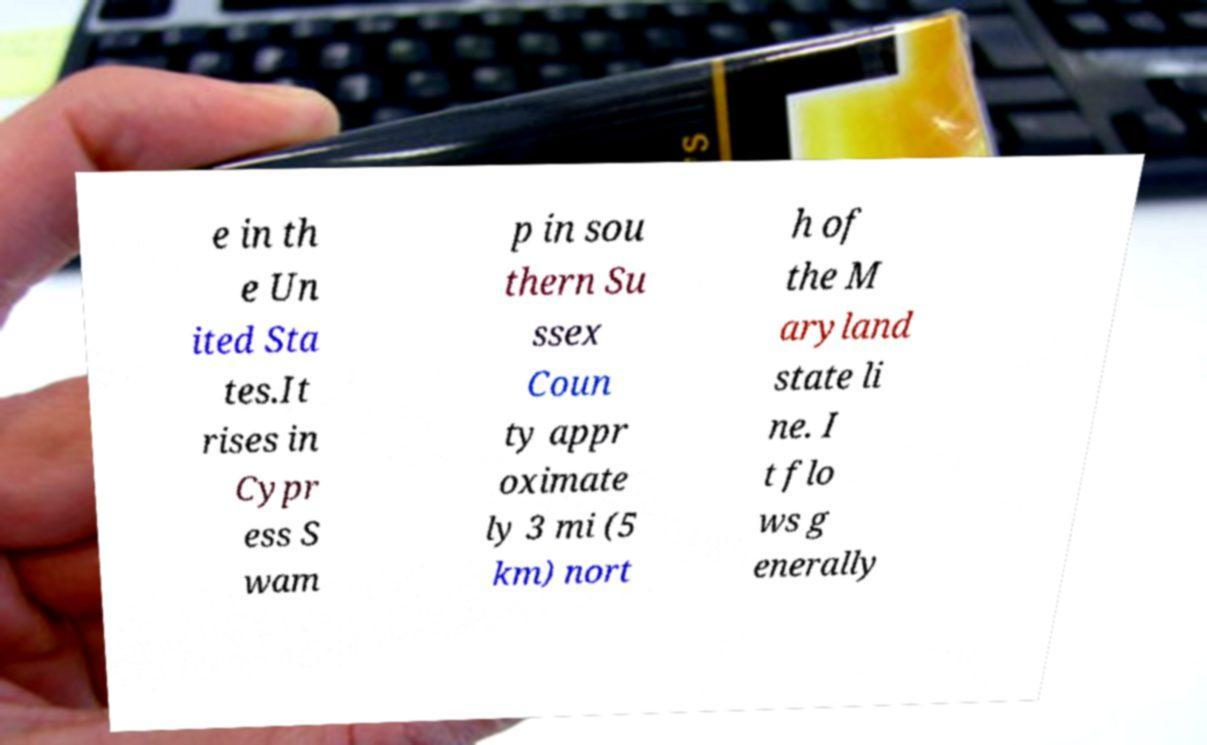For documentation purposes, I need the text within this image transcribed. Could you provide that? e in th e Un ited Sta tes.It rises in Cypr ess S wam p in sou thern Su ssex Coun ty appr oximate ly 3 mi (5 km) nort h of the M aryland state li ne. I t flo ws g enerally 